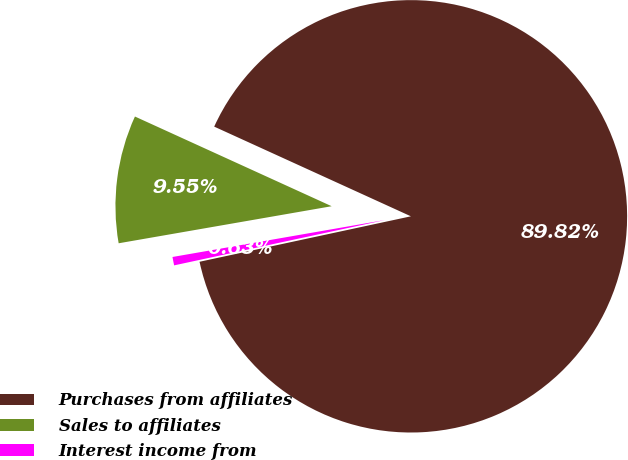<chart> <loc_0><loc_0><loc_500><loc_500><pie_chart><fcel>Purchases from affiliates<fcel>Sales to affiliates<fcel>Interest income from<nl><fcel>89.82%<fcel>9.55%<fcel>0.63%<nl></chart> 